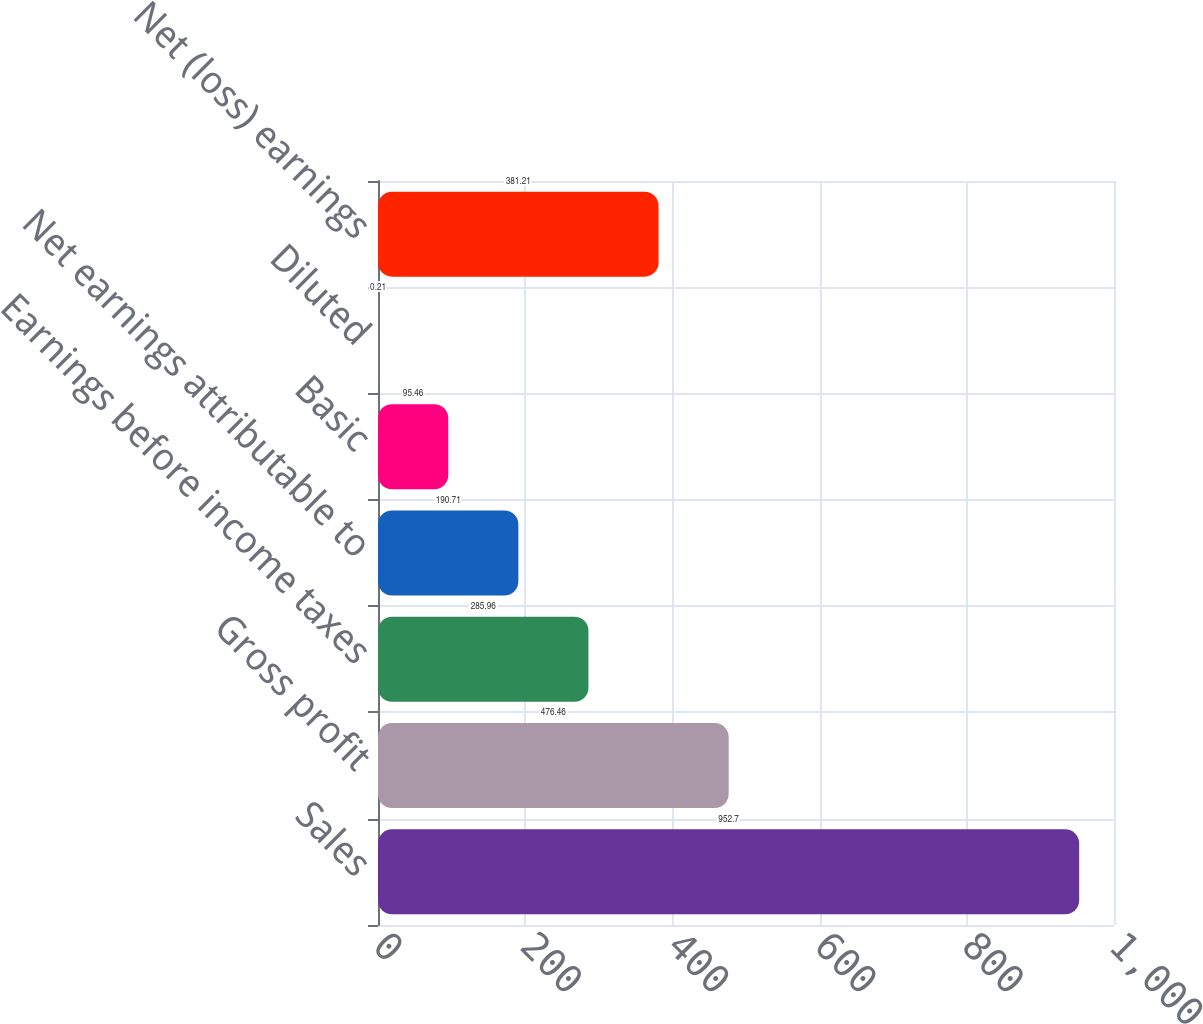Convert chart to OTSL. <chart><loc_0><loc_0><loc_500><loc_500><bar_chart><fcel>Sales<fcel>Gross profit<fcel>Earnings before income taxes<fcel>Net earnings attributable to<fcel>Basic<fcel>Diluted<fcel>Net (loss) earnings<nl><fcel>952.7<fcel>476.46<fcel>285.96<fcel>190.71<fcel>95.46<fcel>0.21<fcel>381.21<nl></chart> 